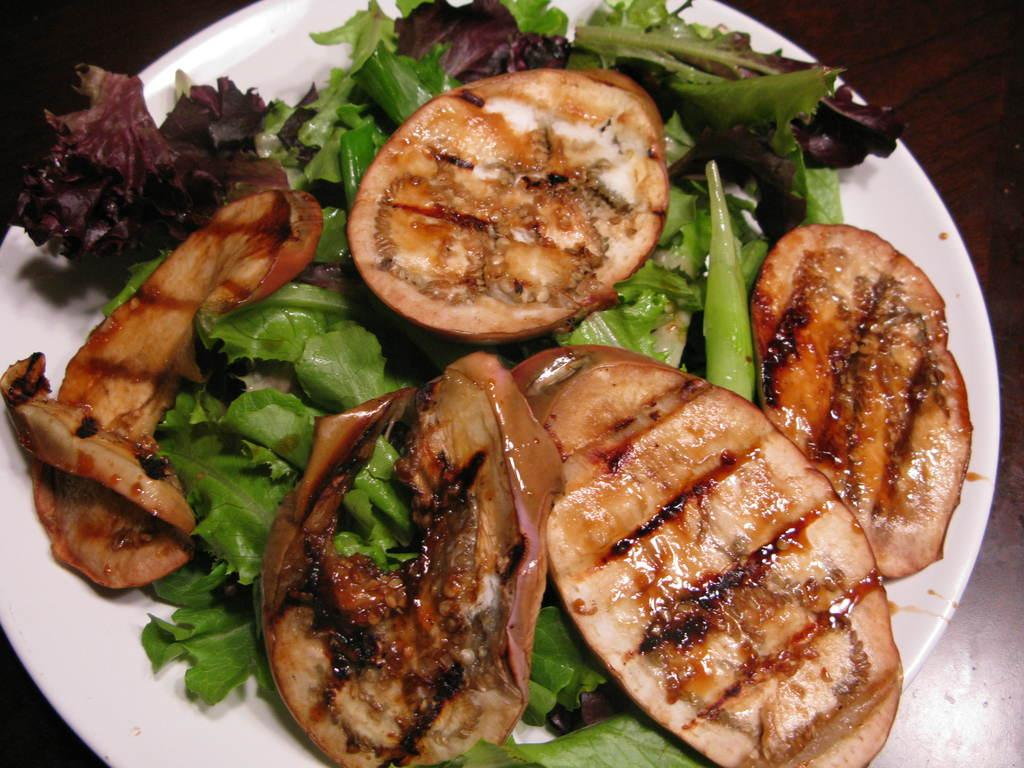What is on the plate that is visible in the image? There is food on a plate in the image, specifically salad. What color is the plate in the image? The plate is white. What can be seen in the background of the image? The background of the image is dark. What type of weather can be seen in the image? There is no indication of weather in the image, as it focuses on a plate of food. What type of apparel is the person in the image wearing? There is no person visible in the image, so it is not possible to determine what type of apparel they might be wearing. 